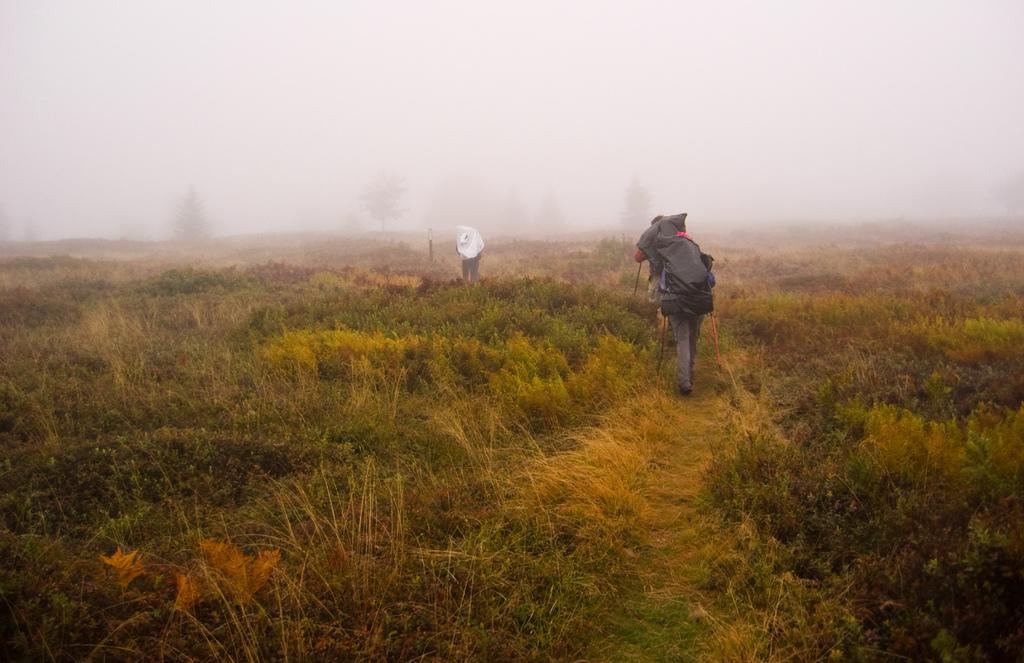Please provide a concise description of this image. In this picture we can see some people walking here, this person is carrying a backpack, at the bottom there is grass, we can see fog and some trees in the background. 